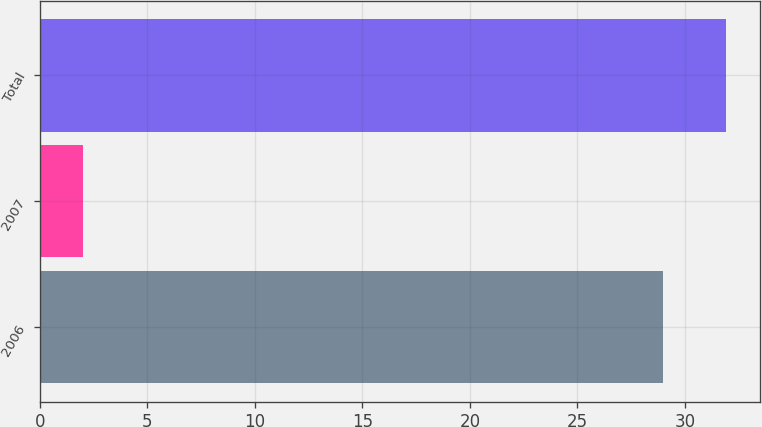<chart> <loc_0><loc_0><loc_500><loc_500><bar_chart><fcel>2006<fcel>2007<fcel>Total<nl><fcel>29<fcel>2<fcel>31.9<nl></chart> 